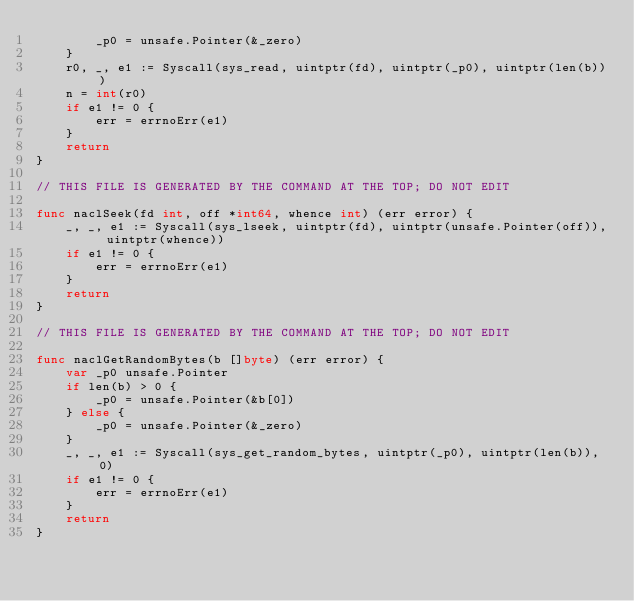Convert code to text. <code><loc_0><loc_0><loc_500><loc_500><_Go_>		_p0 = unsafe.Pointer(&_zero)
	}
	r0, _, e1 := Syscall(sys_read, uintptr(fd), uintptr(_p0), uintptr(len(b)))
	n = int(r0)
	if e1 != 0 {
		err = errnoErr(e1)
	}
	return
}

// THIS FILE IS GENERATED BY THE COMMAND AT THE TOP; DO NOT EDIT

func naclSeek(fd int, off *int64, whence int) (err error) {
	_, _, e1 := Syscall(sys_lseek, uintptr(fd), uintptr(unsafe.Pointer(off)), uintptr(whence))
	if e1 != 0 {
		err = errnoErr(e1)
	}
	return
}

// THIS FILE IS GENERATED BY THE COMMAND AT THE TOP; DO NOT EDIT

func naclGetRandomBytes(b []byte) (err error) {
	var _p0 unsafe.Pointer
	if len(b) > 0 {
		_p0 = unsafe.Pointer(&b[0])
	} else {
		_p0 = unsafe.Pointer(&_zero)
	}
	_, _, e1 := Syscall(sys_get_random_bytes, uintptr(_p0), uintptr(len(b)), 0)
	if e1 != 0 {
		err = errnoErr(e1)
	}
	return
}
</code> 